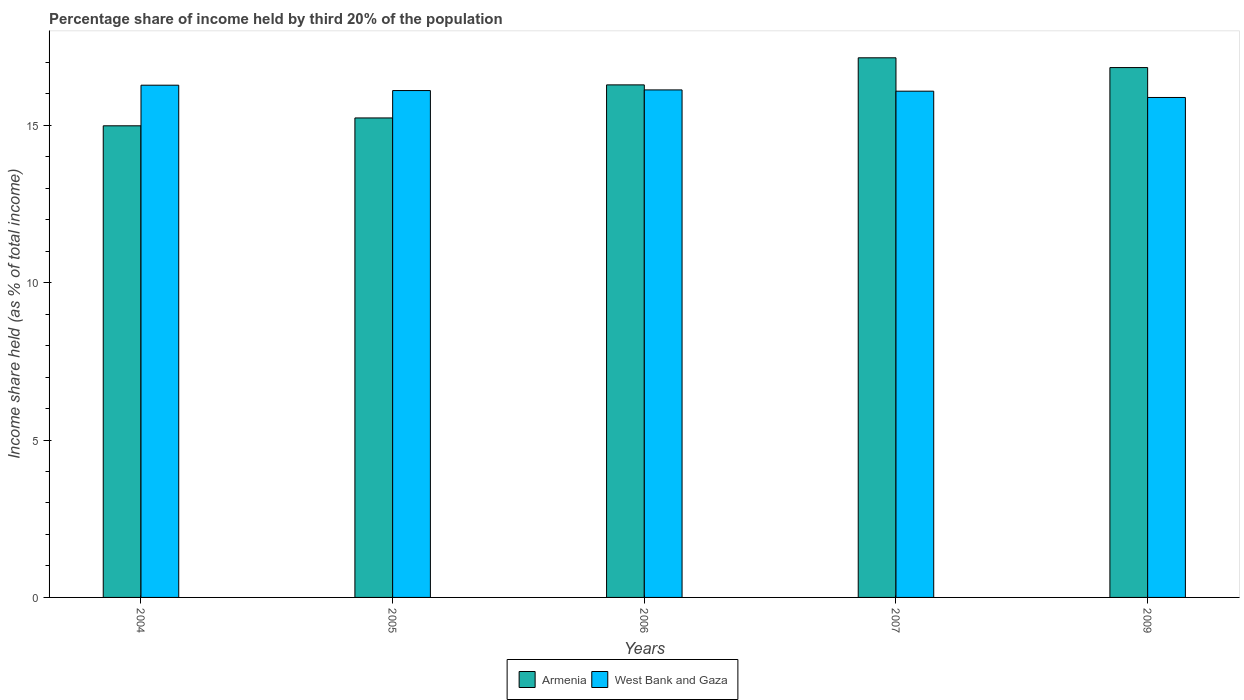How many groups of bars are there?
Your answer should be compact. 5. Are the number of bars per tick equal to the number of legend labels?
Your response must be concise. Yes. Are the number of bars on each tick of the X-axis equal?
Keep it short and to the point. Yes. How many bars are there on the 3rd tick from the left?
Provide a succinct answer. 2. In how many cases, is the number of bars for a given year not equal to the number of legend labels?
Ensure brevity in your answer.  0. What is the share of income held by third 20% of the population in West Bank and Gaza in 2007?
Make the answer very short. 16.08. Across all years, what is the maximum share of income held by third 20% of the population in West Bank and Gaza?
Keep it short and to the point. 16.27. Across all years, what is the minimum share of income held by third 20% of the population in West Bank and Gaza?
Make the answer very short. 15.88. In which year was the share of income held by third 20% of the population in West Bank and Gaza maximum?
Provide a succinct answer. 2004. What is the total share of income held by third 20% of the population in Armenia in the graph?
Ensure brevity in your answer.  80.46. What is the difference between the share of income held by third 20% of the population in West Bank and Gaza in 2005 and that in 2006?
Your answer should be compact. -0.02. What is the difference between the share of income held by third 20% of the population in Armenia in 2005 and the share of income held by third 20% of the population in West Bank and Gaza in 2009?
Offer a terse response. -0.65. What is the average share of income held by third 20% of the population in West Bank and Gaza per year?
Give a very brief answer. 16.09. In the year 2005, what is the difference between the share of income held by third 20% of the population in Armenia and share of income held by third 20% of the population in West Bank and Gaza?
Provide a short and direct response. -0.87. In how many years, is the share of income held by third 20% of the population in West Bank and Gaza greater than 12 %?
Keep it short and to the point. 5. What is the ratio of the share of income held by third 20% of the population in Armenia in 2005 to that in 2006?
Provide a short and direct response. 0.94. What is the difference between the highest and the second highest share of income held by third 20% of the population in West Bank and Gaza?
Give a very brief answer. 0.15. What is the difference between the highest and the lowest share of income held by third 20% of the population in Armenia?
Provide a succinct answer. 2.16. Is the sum of the share of income held by third 20% of the population in West Bank and Gaza in 2004 and 2009 greater than the maximum share of income held by third 20% of the population in Armenia across all years?
Keep it short and to the point. Yes. What does the 1st bar from the left in 2007 represents?
Your answer should be compact. Armenia. What does the 1st bar from the right in 2007 represents?
Make the answer very short. West Bank and Gaza. How many bars are there?
Provide a short and direct response. 10. How many years are there in the graph?
Provide a succinct answer. 5. What is the difference between two consecutive major ticks on the Y-axis?
Provide a succinct answer. 5. Are the values on the major ticks of Y-axis written in scientific E-notation?
Your answer should be very brief. No. Does the graph contain any zero values?
Provide a short and direct response. No. Does the graph contain grids?
Offer a terse response. No. Where does the legend appear in the graph?
Your answer should be very brief. Bottom center. How many legend labels are there?
Your answer should be compact. 2. What is the title of the graph?
Offer a very short reply. Percentage share of income held by third 20% of the population. What is the label or title of the X-axis?
Keep it short and to the point. Years. What is the label or title of the Y-axis?
Provide a succinct answer. Income share held (as % of total income). What is the Income share held (as % of total income) of Armenia in 2004?
Your answer should be very brief. 14.98. What is the Income share held (as % of total income) of West Bank and Gaza in 2004?
Keep it short and to the point. 16.27. What is the Income share held (as % of total income) of Armenia in 2005?
Give a very brief answer. 15.23. What is the Income share held (as % of total income) of Armenia in 2006?
Ensure brevity in your answer.  16.28. What is the Income share held (as % of total income) in West Bank and Gaza in 2006?
Keep it short and to the point. 16.12. What is the Income share held (as % of total income) of Armenia in 2007?
Give a very brief answer. 17.14. What is the Income share held (as % of total income) of West Bank and Gaza in 2007?
Your response must be concise. 16.08. What is the Income share held (as % of total income) of Armenia in 2009?
Make the answer very short. 16.83. What is the Income share held (as % of total income) in West Bank and Gaza in 2009?
Your response must be concise. 15.88. Across all years, what is the maximum Income share held (as % of total income) of Armenia?
Provide a short and direct response. 17.14. Across all years, what is the maximum Income share held (as % of total income) in West Bank and Gaza?
Provide a succinct answer. 16.27. Across all years, what is the minimum Income share held (as % of total income) in Armenia?
Offer a terse response. 14.98. Across all years, what is the minimum Income share held (as % of total income) of West Bank and Gaza?
Give a very brief answer. 15.88. What is the total Income share held (as % of total income) in Armenia in the graph?
Your response must be concise. 80.46. What is the total Income share held (as % of total income) in West Bank and Gaza in the graph?
Make the answer very short. 80.45. What is the difference between the Income share held (as % of total income) of Armenia in 2004 and that in 2005?
Your answer should be compact. -0.25. What is the difference between the Income share held (as % of total income) of West Bank and Gaza in 2004 and that in 2005?
Provide a short and direct response. 0.17. What is the difference between the Income share held (as % of total income) in Armenia in 2004 and that in 2007?
Offer a very short reply. -2.16. What is the difference between the Income share held (as % of total income) of West Bank and Gaza in 2004 and that in 2007?
Ensure brevity in your answer.  0.19. What is the difference between the Income share held (as % of total income) in Armenia in 2004 and that in 2009?
Offer a very short reply. -1.85. What is the difference between the Income share held (as % of total income) in West Bank and Gaza in 2004 and that in 2009?
Keep it short and to the point. 0.39. What is the difference between the Income share held (as % of total income) of Armenia in 2005 and that in 2006?
Your response must be concise. -1.05. What is the difference between the Income share held (as % of total income) of West Bank and Gaza in 2005 and that in 2006?
Provide a succinct answer. -0.02. What is the difference between the Income share held (as % of total income) in Armenia in 2005 and that in 2007?
Offer a terse response. -1.91. What is the difference between the Income share held (as % of total income) of West Bank and Gaza in 2005 and that in 2009?
Your answer should be compact. 0.22. What is the difference between the Income share held (as % of total income) in Armenia in 2006 and that in 2007?
Make the answer very short. -0.86. What is the difference between the Income share held (as % of total income) in West Bank and Gaza in 2006 and that in 2007?
Provide a succinct answer. 0.04. What is the difference between the Income share held (as % of total income) of Armenia in 2006 and that in 2009?
Keep it short and to the point. -0.55. What is the difference between the Income share held (as % of total income) in West Bank and Gaza in 2006 and that in 2009?
Offer a terse response. 0.24. What is the difference between the Income share held (as % of total income) in Armenia in 2007 and that in 2009?
Give a very brief answer. 0.31. What is the difference between the Income share held (as % of total income) of West Bank and Gaza in 2007 and that in 2009?
Ensure brevity in your answer.  0.2. What is the difference between the Income share held (as % of total income) of Armenia in 2004 and the Income share held (as % of total income) of West Bank and Gaza in 2005?
Provide a short and direct response. -1.12. What is the difference between the Income share held (as % of total income) of Armenia in 2004 and the Income share held (as % of total income) of West Bank and Gaza in 2006?
Provide a succinct answer. -1.14. What is the difference between the Income share held (as % of total income) in Armenia in 2004 and the Income share held (as % of total income) in West Bank and Gaza in 2009?
Offer a very short reply. -0.9. What is the difference between the Income share held (as % of total income) in Armenia in 2005 and the Income share held (as % of total income) in West Bank and Gaza in 2006?
Your answer should be compact. -0.89. What is the difference between the Income share held (as % of total income) of Armenia in 2005 and the Income share held (as % of total income) of West Bank and Gaza in 2007?
Offer a terse response. -0.85. What is the difference between the Income share held (as % of total income) in Armenia in 2005 and the Income share held (as % of total income) in West Bank and Gaza in 2009?
Provide a succinct answer. -0.65. What is the difference between the Income share held (as % of total income) in Armenia in 2007 and the Income share held (as % of total income) in West Bank and Gaza in 2009?
Provide a succinct answer. 1.26. What is the average Income share held (as % of total income) in Armenia per year?
Give a very brief answer. 16.09. What is the average Income share held (as % of total income) of West Bank and Gaza per year?
Your answer should be compact. 16.09. In the year 2004, what is the difference between the Income share held (as % of total income) of Armenia and Income share held (as % of total income) of West Bank and Gaza?
Offer a terse response. -1.29. In the year 2005, what is the difference between the Income share held (as % of total income) of Armenia and Income share held (as % of total income) of West Bank and Gaza?
Provide a succinct answer. -0.87. In the year 2006, what is the difference between the Income share held (as % of total income) in Armenia and Income share held (as % of total income) in West Bank and Gaza?
Ensure brevity in your answer.  0.16. In the year 2007, what is the difference between the Income share held (as % of total income) in Armenia and Income share held (as % of total income) in West Bank and Gaza?
Offer a terse response. 1.06. What is the ratio of the Income share held (as % of total income) of Armenia in 2004 to that in 2005?
Keep it short and to the point. 0.98. What is the ratio of the Income share held (as % of total income) of West Bank and Gaza in 2004 to that in 2005?
Your answer should be compact. 1.01. What is the ratio of the Income share held (as % of total income) of Armenia in 2004 to that in 2006?
Offer a terse response. 0.92. What is the ratio of the Income share held (as % of total income) of West Bank and Gaza in 2004 to that in 2006?
Offer a terse response. 1.01. What is the ratio of the Income share held (as % of total income) in Armenia in 2004 to that in 2007?
Provide a short and direct response. 0.87. What is the ratio of the Income share held (as % of total income) of West Bank and Gaza in 2004 to that in 2007?
Make the answer very short. 1.01. What is the ratio of the Income share held (as % of total income) in Armenia in 2004 to that in 2009?
Provide a succinct answer. 0.89. What is the ratio of the Income share held (as % of total income) in West Bank and Gaza in 2004 to that in 2009?
Provide a short and direct response. 1.02. What is the ratio of the Income share held (as % of total income) in Armenia in 2005 to that in 2006?
Your answer should be very brief. 0.94. What is the ratio of the Income share held (as % of total income) in Armenia in 2005 to that in 2007?
Your answer should be compact. 0.89. What is the ratio of the Income share held (as % of total income) of West Bank and Gaza in 2005 to that in 2007?
Make the answer very short. 1. What is the ratio of the Income share held (as % of total income) in Armenia in 2005 to that in 2009?
Ensure brevity in your answer.  0.9. What is the ratio of the Income share held (as % of total income) of West Bank and Gaza in 2005 to that in 2009?
Offer a terse response. 1.01. What is the ratio of the Income share held (as % of total income) of Armenia in 2006 to that in 2007?
Provide a short and direct response. 0.95. What is the ratio of the Income share held (as % of total income) of West Bank and Gaza in 2006 to that in 2007?
Offer a very short reply. 1. What is the ratio of the Income share held (as % of total income) of Armenia in 2006 to that in 2009?
Give a very brief answer. 0.97. What is the ratio of the Income share held (as % of total income) in West Bank and Gaza in 2006 to that in 2009?
Offer a terse response. 1.02. What is the ratio of the Income share held (as % of total income) in Armenia in 2007 to that in 2009?
Offer a very short reply. 1.02. What is the ratio of the Income share held (as % of total income) of West Bank and Gaza in 2007 to that in 2009?
Your response must be concise. 1.01. What is the difference between the highest and the second highest Income share held (as % of total income) in Armenia?
Your answer should be very brief. 0.31. What is the difference between the highest and the lowest Income share held (as % of total income) in Armenia?
Keep it short and to the point. 2.16. What is the difference between the highest and the lowest Income share held (as % of total income) in West Bank and Gaza?
Provide a short and direct response. 0.39. 